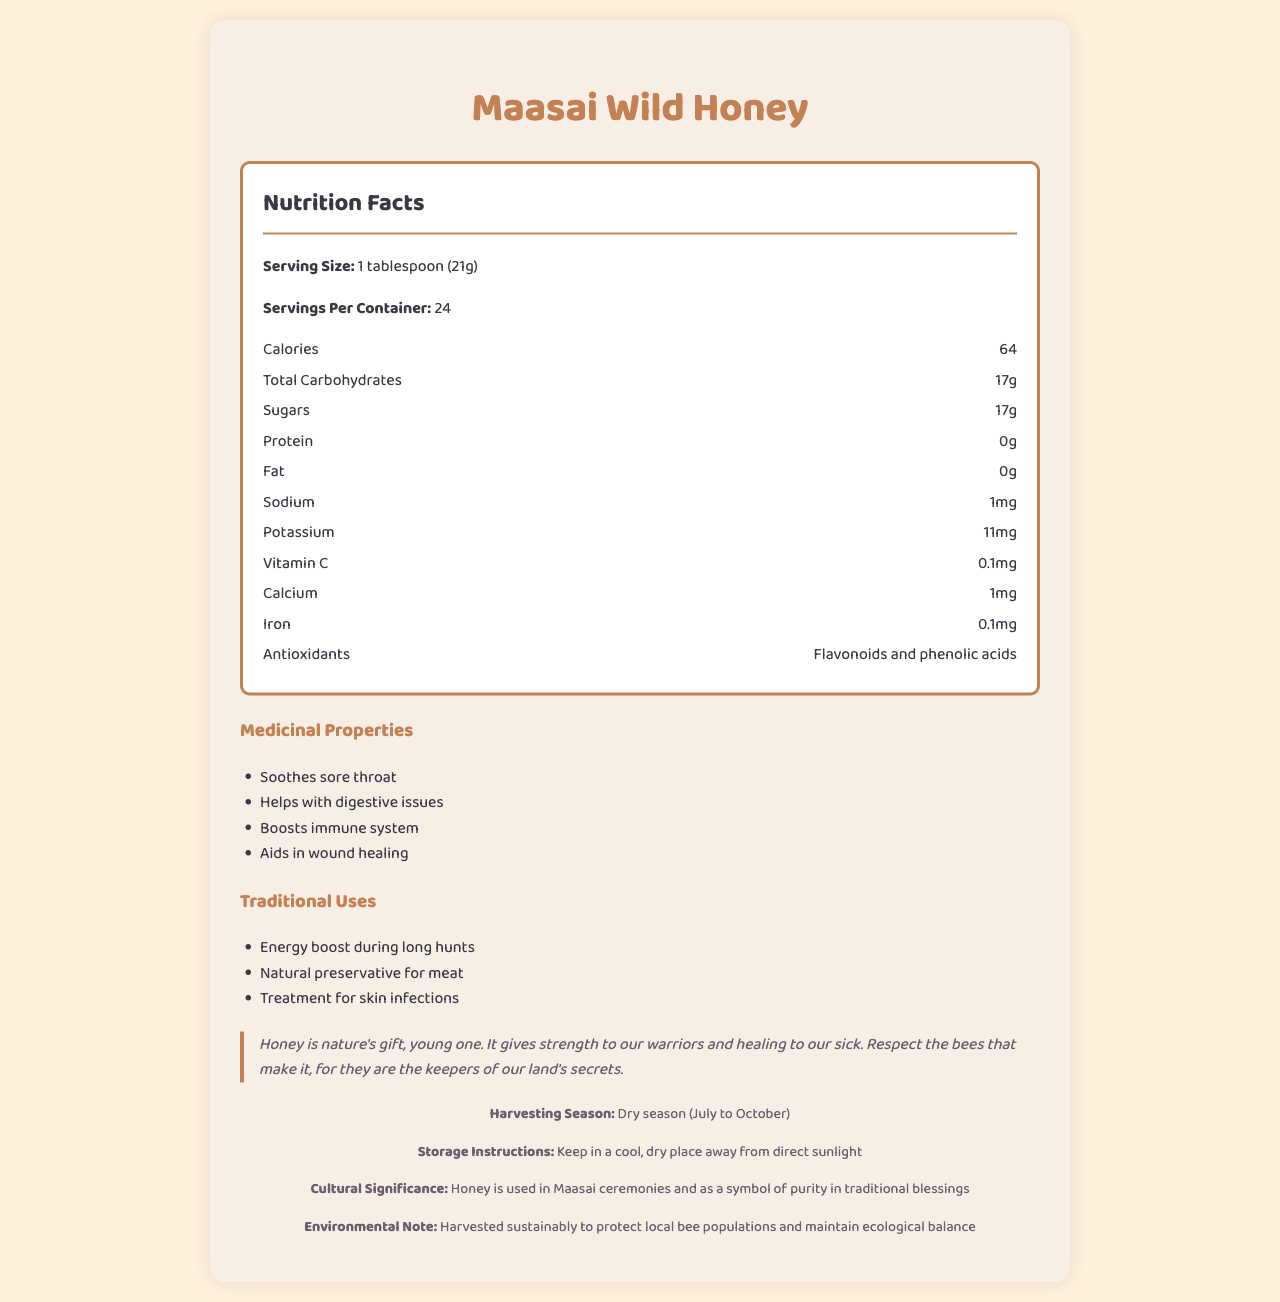What is the serving size for Maasai Wild Honey? The serving size is listed as "1 tablespoon (21g)" in the nutrition facts section of the document.
Answer: 1 tablespoon (21g) How many calories are there per serving? The document states that there are 64 calories per serving.
Answer: 64 What is the amount of sugars in one serving? The amount of sugars per serving is listed as 17g.
Answer: 17g Which of the following medicinal properties does Maasai Wild Honey have? A. Reduces blood sugar B. Soothes sore throat C. Enhances vision D. Increases appetite According to the document, one of the medicinal properties is "Soothes sore throat."
Answer: B For what purpose is honey used traditionally by the Maasai during long hunts? The document mentions that honey is used as an energy boost during long hunts.
Answer: Energy boost Is Maasai Wild Honey a good source of protein? The nutrition facts show that it contains 0g of protein, indicating that it is not a source of protein.
Answer: No What is the traditional use of honey for skin infections? Treatment for skin infections is listed as a traditional use under "traditional uses".
Answer: Treatment for skin infections During which months is Maasai Wild Honey harvested? A. January to March B. April to June C. July to October D. November to December The document states that the harvesting season is the dry season from July to October.
Answer: C Should Maasai Wild Honey be kept in the refrigerator? The storage instructions specify to keep it in a cool, dry place away from direct sunlight, with no mention of refrigeration.
Answer: No What antioxidants are found in Maasai Wild Honey? The document lists the antioxidants as "Flavonoids and phenolic acids."
Answer: Flavonoids and phenolic acids Does Maasai Wild Honey aid in wound healing? The medicinal properties section includes "Aids in wound healing."
Answer: Yes Describe the main idea of the document. The entire document elaborates on various aspects of Maasai Wild Honey, including its nutritional values, medicinal benefits, cultural importance, and traditional uses, along with specific instructions for storage and details about its harvesting season.
Answer: The document provides detailed nutrition facts, medicinal properties, traditional uses, cultural significance, and storage instructions for Maasai Wild Honey. It highlights its health benefits, traditional applications, and the importance of sustainable harvesting. What is the average annual rainfall in the area where Maasai Wild Honey is harvested? The document does not provide any information regarding the average annual rainfall in the area where the honey is harvested.
Answer: Cannot be determined 